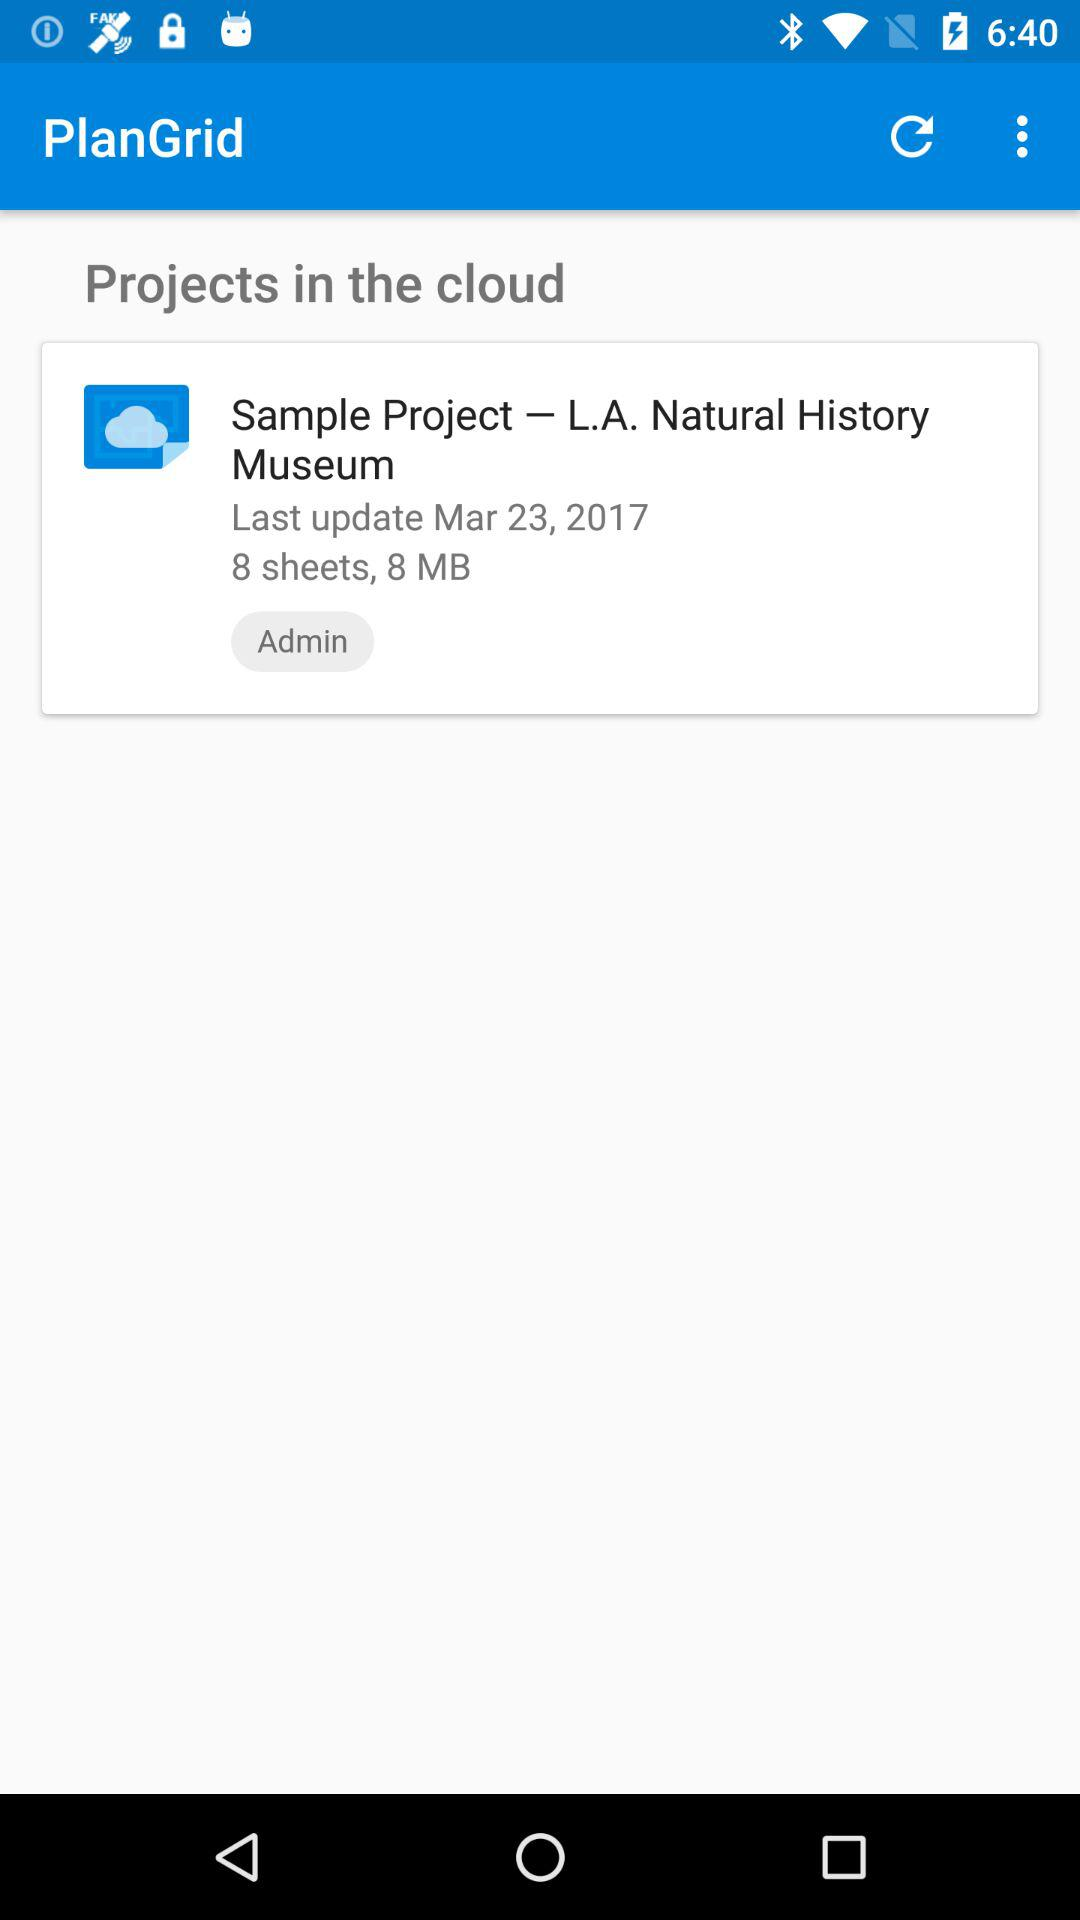Is "Projects in the cloud" checked or unchecked?
When the provided information is insufficient, respond with <no answer>. <no answer> 